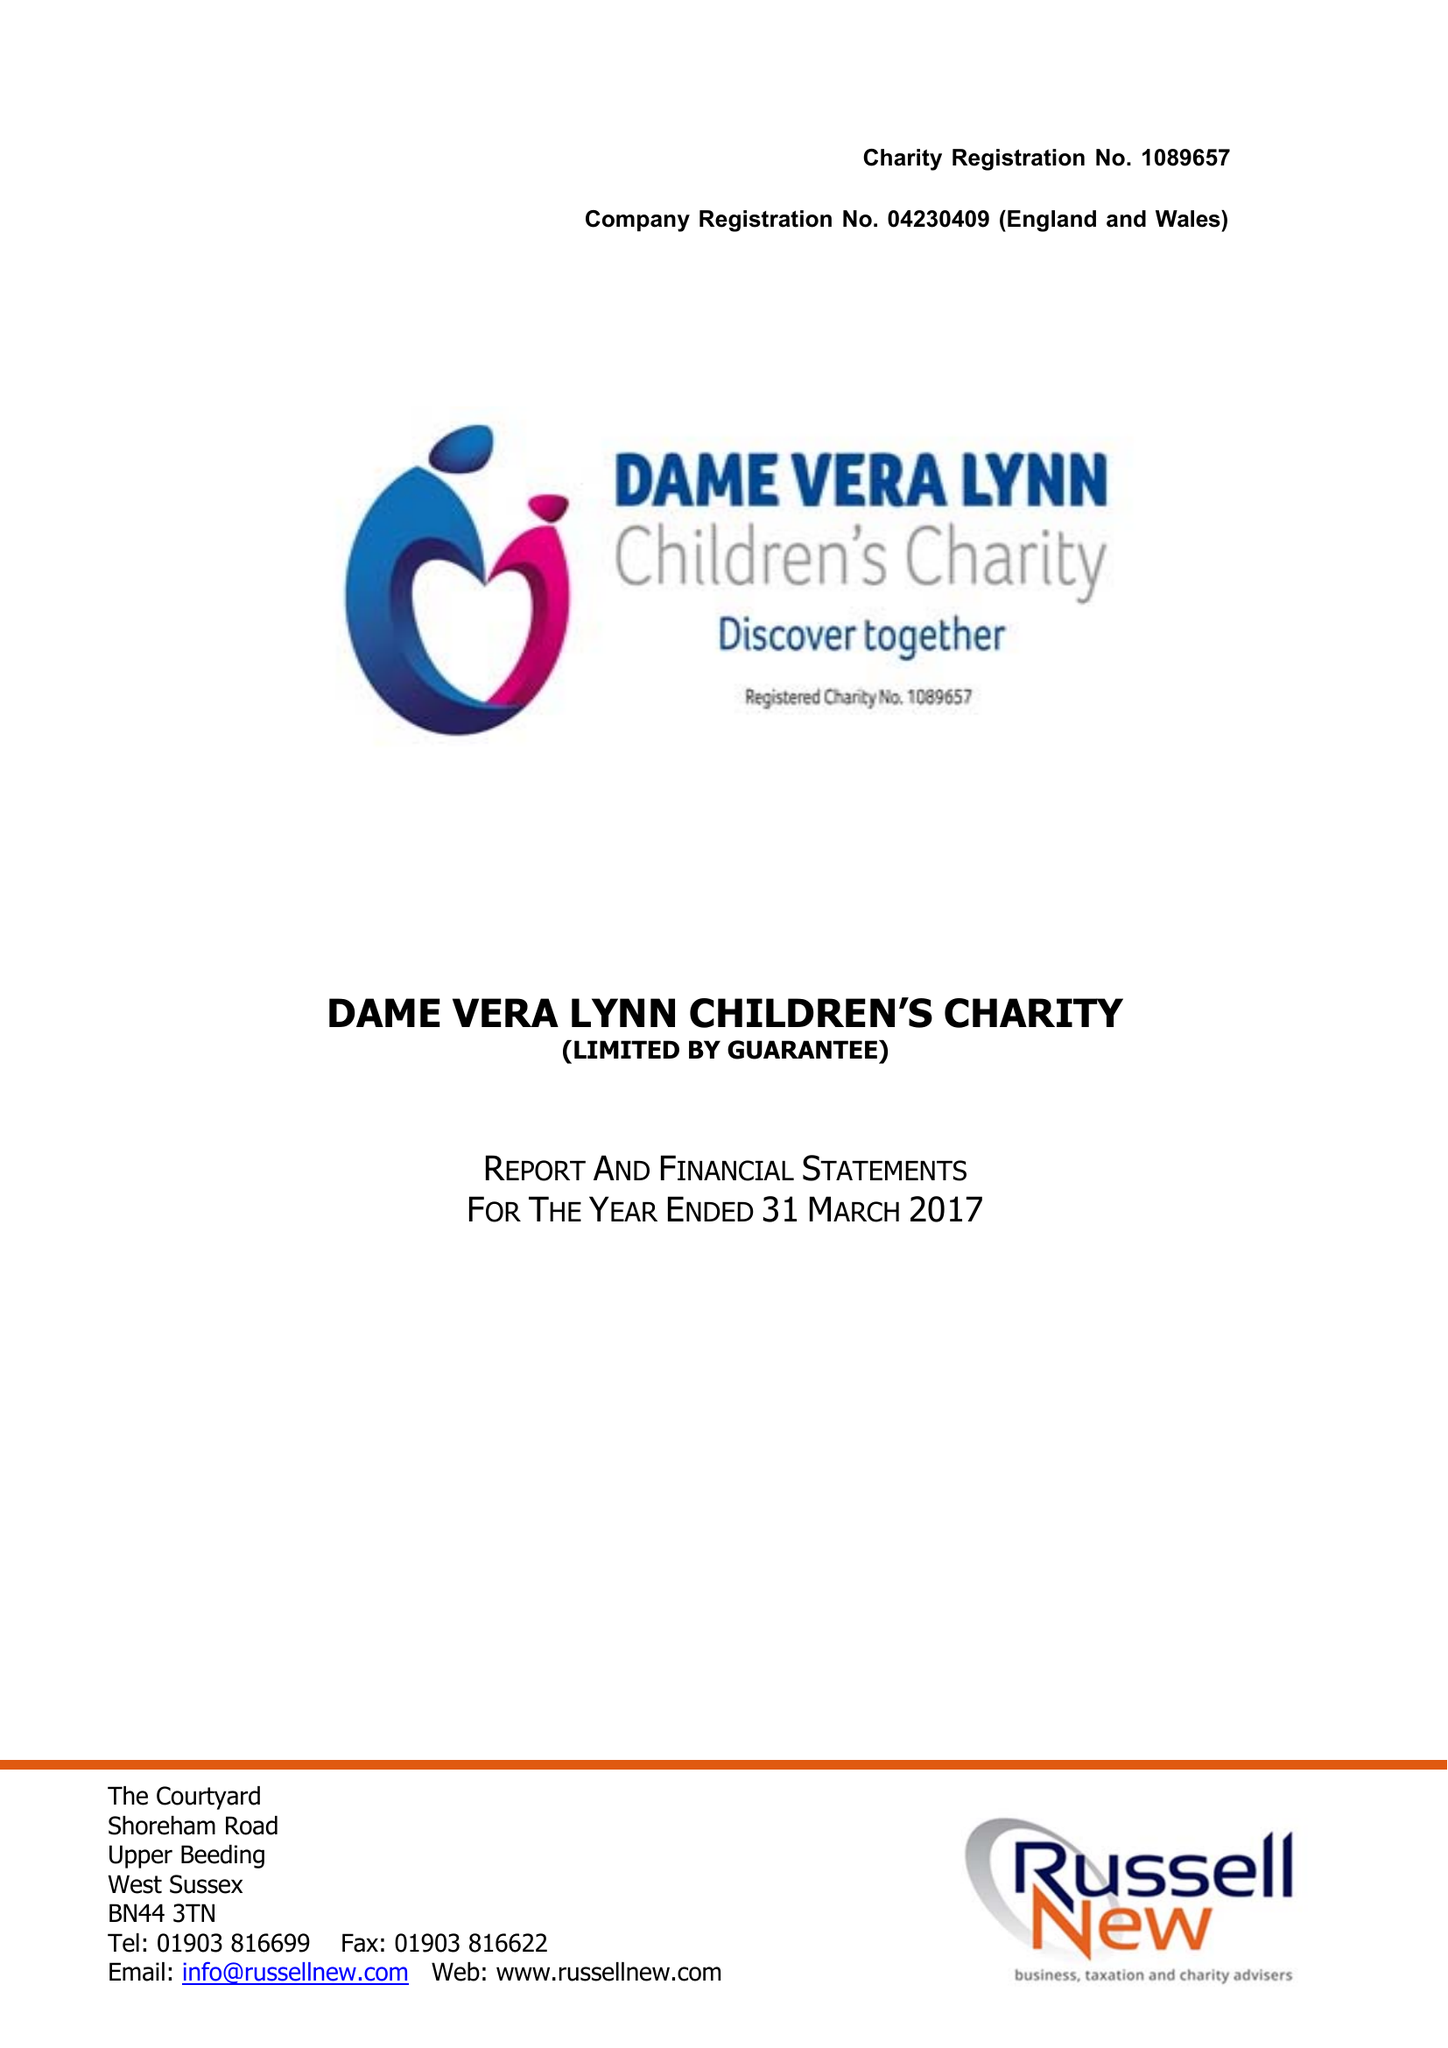What is the value for the address__street_line?
Answer the question using a single word or phrase. STAPLEFIELD ROAD 